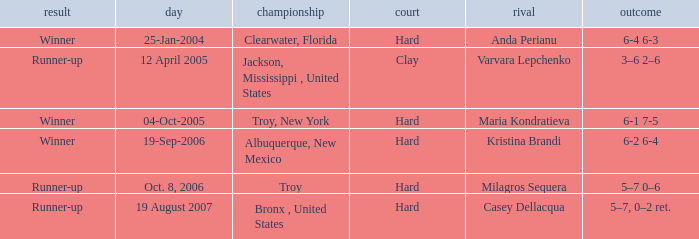Where was the tournament played on Oct. 8, 2006? Troy. 